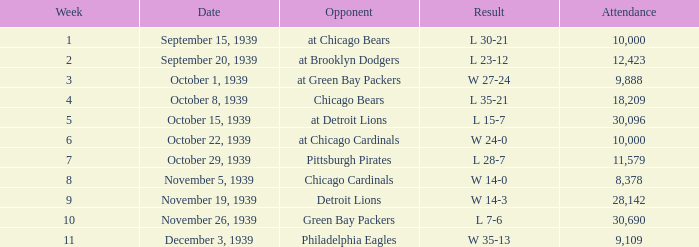What sum of Attendance has a Week smaller than 10, and a Result of l 30-21? 10000.0. 